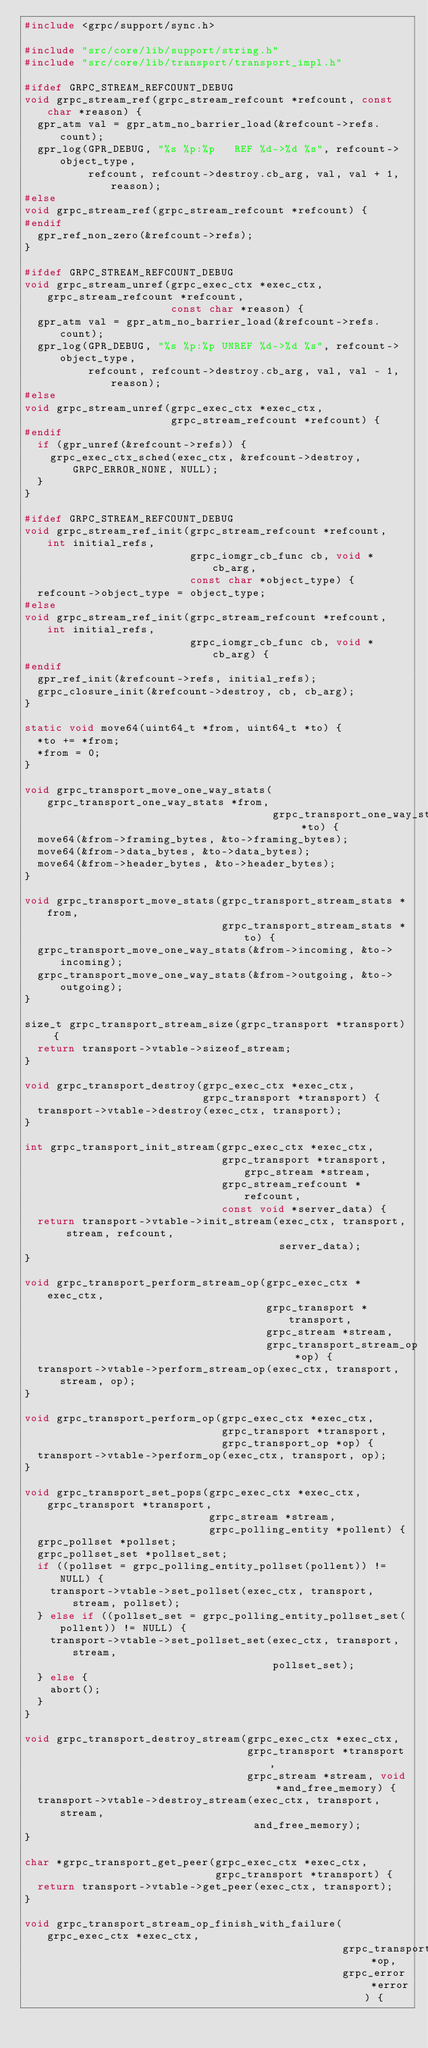Convert code to text. <code><loc_0><loc_0><loc_500><loc_500><_C_>#include <grpc/support/sync.h>

#include "src/core/lib/support/string.h"
#include "src/core/lib/transport/transport_impl.h"

#ifdef GRPC_STREAM_REFCOUNT_DEBUG
void grpc_stream_ref(grpc_stream_refcount *refcount, const char *reason) {
  gpr_atm val = gpr_atm_no_barrier_load(&refcount->refs.count);
  gpr_log(GPR_DEBUG, "%s %p:%p   REF %d->%d %s", refcount->object_type,
          refcount, refcount->destroy.cb_arg, val, val + 1, reason);
#else
void grpc_stream_ref(grpc_stream_refcount *refcount) {
#endif
  gpr_ref_non_zero(&refcount->refs);
}

#ifdef GRPC_STREAM_REFCOUNT_DEBUG
void grpc_stream_unref(grpc_exec_ctx *exec_ctx, grpc_stream_refcount *refcount,
                       const char *reason) {
  gpr_atm val = gpr_atm_no_barrier_load(&refcount->refs.count);
  gpr_log(GPR_DEBUG, "%s %p:%p UNREF %d->%d %s", refcount->object_type,
          refcount, refcount->destroy.cb_arg, val, val - 1, reason);
#else
void grpc_stream_unref(grpc_exec_ctx *exec_ctx,
                       grpc_stream_refcount *refcount) {
#endif
  if (gpr_unref(&refcount->refs)) {
    grpc_exec_ctx_sched(exec_ctx, &refcount->destroy, GRPC_ERROR_NONE, NULL);
  }
}

#ifdef GRPC_STREAM_REFCOUNT_DEBUG
void grpc_stream_ref_init(grpc_stream_refcount *refcount, int initial_refs,
                          grpc_iomgr_cb_func cb, void *cb_arg,
                          const char *object_type) {
  refcount->object_type = object_type;
#else
void grpc_stream_ref_init(grpc_stream_refcount *refcount, int initial_refs,
                          grpc_iomgr_cb_func cb, void *cb_arg) {
#endif
  gpr_ref_init(&refcount->refs, initial_refs);
  grpc_closure_init(&refcount->destroy, cb, cb_arg);
}

static void move64(uint64_t *from, uint64_t *to) {
  *to += *from;
  *from = 0;
}

void grpc_transport_move_one_way_stats(grpc_transport_one_way_stats *from,
                                       grpc_transport_one_way_stats *to) {
  move64(&from->framing_bytes, &to->framing_bytes);
  move64(&from->data_bytes, &to->data_bytes);
  move64(&from->header_bytes, &to->header_bytes);
}

void grpc_transport_move_stats(grpc_transport_stream_stats *from,
                               grpc_transport_stream_stats *to) {
  grpc_transport_move_one_way_stats(&from->incoming, &to->incoming);
  grpc_transport_move_one_way_stats(&from->outgoing, &to->outgoing);
}

size_t grpc_transport_stream_size(grpc_transport *transport) {
  return transport->vtable->sizeof_stream;
}

void grpc_transport_destroy(grpc_exec_ctx *exec_ctx,
                            grpc_transport *transport) {
  transport->vtable->destroy(exec_ctx, transport);
}

int grpc_transport_init_stream(grpc_exec_ctx *exec_ctx,
                               grpc_transport *transport, grpc_stream *stream,
                               grpc_stream_refcount *refcount,
                               const void *server_data) {
  return transport->vtable->init_stream(exec_ctx, transport, stream, refcount,
                                        server_data);
}

void grpc_transport_perform_stream_op(grpc_exec_ctx *exec_ctx,
                                      grpc_transport *transport,
                                      grpc_stream *stream,
                                      grpc_transport_stream_op *op) {
  transport->vtable->perform_stream_op(exec_ctx, transport, stream, op);
}

void grpc_transport_perform_op(grpc_exec_ctx *exec_ctx,
                               grpc_transport *transport,
                               grpc_transport_op *op) {
  transport->vtable->perform_op(exec_ctx, transport, op);
}

void grpc_transport_set_pops(grpc_exec_ctx *exec_ctx, grpc_transport *transport,
                             grpc_stream *stream,
                             grpc_polling_entity *pollent) {
  grpc_pollset *pollset;
  grpc_pollset_set *pollset_set;
  if ((pollset = grpc_polling_entity_pollset(pollent)) != NULL) {
    transport->vtable->set_pollset(exec_ctx, transport, stream, pollset);
  } else if ((pollset_set = grpc_polling_entity_pollset_set(pollent)) != NULL) {
    transport->vtable->set_pollset_set(exec_ctx, transport, stream,
                                       pollset_set);
  } else {
    abort();
  }
}

void grpc_transport_destroy_stream(grpc_exec_ctx *exec_ctx,
                                   grpc_transport *transport,
                                   grpc_stream *stream, void *and_free_memory) {
  transport->vtable->destroy_stream(exec_ctx, transport, stream,
                                    and_free_memory);
}

char *grpc_transport_get_peer(grpc_exec_ctx *exec_ctx,
                              grpc_transport *transport) {
  return transport->vtable->get_peer(exec_ctx, transport);
}

void grpc_transport_stream_op_finish_with_failure(grpc_exec_ctx *exec_ctx,
                                                  grpc_transport_stream_op *op,
                                                  grpc_error *error) {</code> 